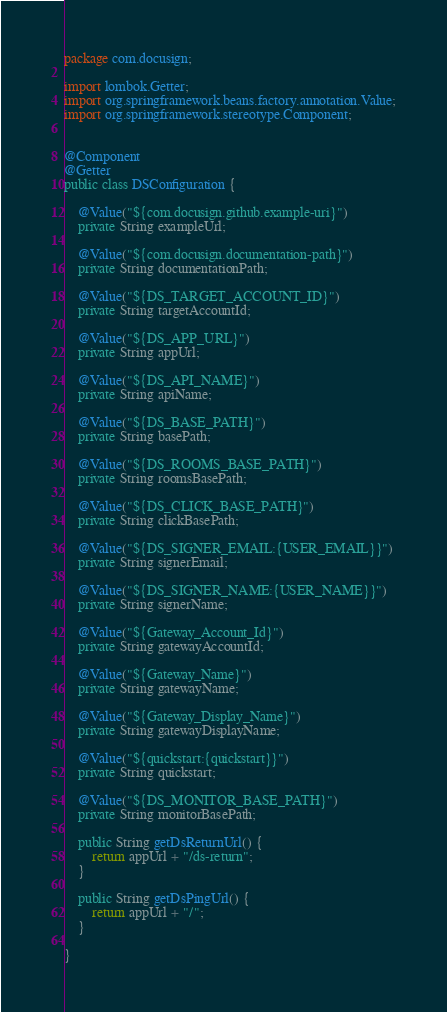Convert code to text. <code><loc_0><loc_0><loc_500><loc_500><_Java_>package com.docusign;

import lombok.Getter;
import org.springframework.beans.factory.annotation.Value;
import org.springframework.stereotype.Component;


@Component
@Getter
public class DSConfiguration {

    @Value("${com.docusign.github.example-uri}")
    private String exampleUrl;

    @Value("${com.docusign.documentation-path}")
    private String documentationPath;

    @Value("${DS_TARGET_ACCOUNT_ID}")
    private String targetAccountId;

    @Value("${DS_APP_URL}")
    private String appUrl;

    @Value("${DS_API_NAME}")
    private String apiName;

    @Value("${DS_BASE_PATH}")
    private String basePath;
    
    @Value("${DS_ROOMS_BASE_PATH}")
    private String roomsBasePath;

    @Value("${DS_CLICK_BASE_PATH}")
    private String clickBasePath;

    @Value("${DS_SIGNER_EMAIL:{USER_EMAIL}}")
    private String signerEmail;

    @Value("${DS_SIGNER_NAME:{USER_NAME}}")
    private String signerName;

    @Value("${Gateway_Account_Id}")
    private String gatewayAccountId;

    @Value("${Gateway_Name}")
    private String gatewayName;

    @Value("${Gateway_Display_Name}")
    private String gatewayDisplayName;

    @Value("${quickstart:{quickstart}}")
    private String quickstart;

    @Value("${DS_MONITOR_BASE_PATH}")
    private String monitorBasePath;

    public String getDsReturnUrl() {
        return appUrl + "/ds-return";
    }

    public String getDsPingUrl() {
        return appUrl + "/";
    }

}
</code> 